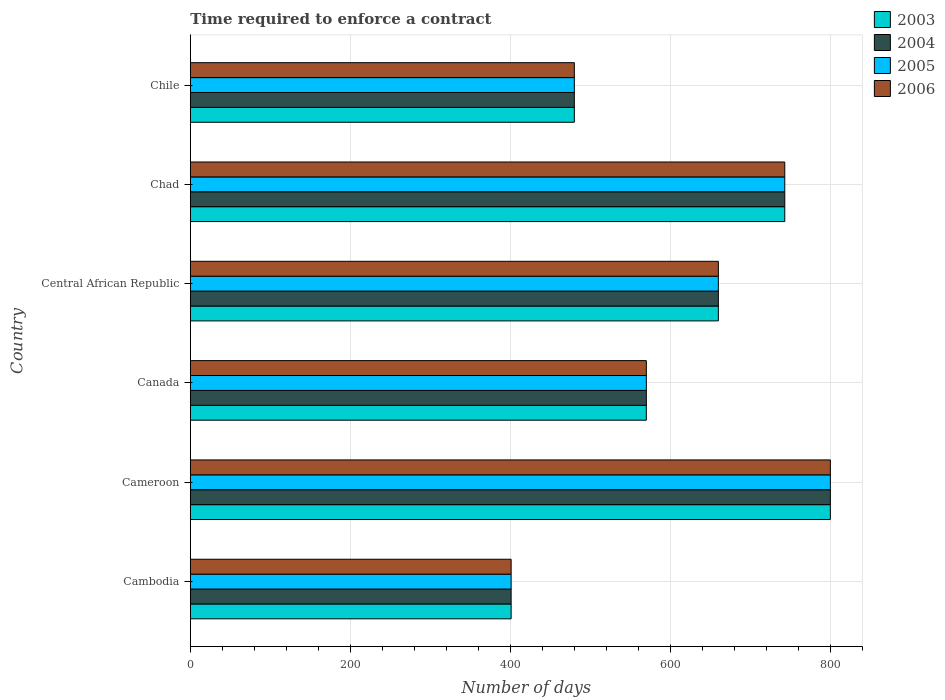How many different coloured bars are there?
Offer a very short reply. 4. How many groups of bars are there?
Provide a short and direct response. 6. How many bars are there on the 3rd tick from the bottom?
Keep it short and to the point. 4. What is the label of the 4th group of bars from the top?
Give a very brief answer. Canada. What is the number of days required to enforce a contract in 2005 in Cameroon?
Provide a short and direct response. 800. Across all countries, what is the maximum number of days required to enforce a contract in 2005?
Provide a succinct answer. 800. Across all countries, what is the minimum number of days required to enforce a contract in 2005?
Offer a terse response. 401. In which country was the number of days required to enforce a contract in 2003 maximum?
Your response must be concise. Cameroon. In which country was the number of days required to enforce a contract in 2005 minimum?
Your response must be concise. Cambodia. What is the total number of days required to enforce a contract in 2003 in the graph?
Provide a short and direct response. 3654. What is the difference between the number of days required to enforce a contract in 2004 in Cameroon and that in Canada?
Make the answer very short. 230. What is the difference between the number of days required to enforce a contract in 2004 in Chile and the number of days required to enforce a contract in 2005 in Canada?
Your answer should be compact. -90. What is the average number of days required to enforce a contract in 2006 per country?
Provide a succinct answer. 609. What is the difference between the number of days required to enforce a contract in 2006 and number of days required to enforce a contract in 2004 in Chad?
Ensure brevity in your answer.  0. In how many countries, is the number of days required to enforce a contract in 2005 greater than 800 days?
Ensure brevity in your answer.  0. What is the ratio of the number of days required to enforce a contract in 2004 in Chad to that in Chile?
Your answer should be very brief. 1.55. Is the difference between the number of days required to enforce a contract in 2006 in Central African Republic and Chile greater than the difference between the number of days required to enforce a contract in 2004 in Central African Republic and Chile?
Make the answer very short. No. What is the difference between the highest and the lowest number of days required to enforce a contract in 2004?
Your answer should be compact. 399. In how many countries, is the number of days required to enforce a contract in 2005 greater than the average number of days required to enforce a contract in 2005 taken over all countries?
Provide a short and direct response. 3. What does the 2nd bar from the bottom in Central African Republic represents?
Offer a very short reply. 2004. Are all the bars in the graph horizontal?
Give a very brief answer. Yes. How many countries are there in the graph?
Make the answer very short. 6. What is the difference between two consecutive major ticks on the X-axis?
Provide a succinct answer. 200. Does the graph contain any zero values?
Give a very brief answer. No. Does the graph contain grids?
Provide a short and direct response. Yes. Where does the legend appear in the graph?
Offer a very short reply. Top right. What is the title of the graph?
Provide a succinct answer. Time required to enforce a contract. Does "2002" appear as one of the legend labels in the graph?
Make the answer very short. No. What is the label or title of the X-axis?
Make the answer very short. Number of days. What is the Number of days of 2003 in Cambodia?
Offer a terse response. 401. What is the Number of days of 2004 in Cambodia?
Make the answer very short. 401. What is the Number of days of 2005 in Cambodia?
Offer a terse response. 401. What is the Number of days in 2006 in Cambodia?
Provide a short and direct response. 401. What is the Number of days of 2003 in Cameroon?
Your answer should be very brief. 800. What is the Number of days of 2004 in Cameroon?
Provide a succinct answer. 800. What is the Number of days of 2005 in Cameroon?
Your answer should be very brief. 800. What is the Number of days in 2006 in Cameroon?
Keep it short and to the point. 800. What is the Number of days of 2003 in Canada?
Offer a very short reply. 570. What is the Number of days of 2004 in Canada?
Ensure brevity in your answer.  570. What is the Number of days in 2005 in Canada?
Offer a terse response. 570. What is the Number of days in 2006 in Canada?
Your response must be concise. 570. What is the Number of days of 2003 in Central African Republic?
Offer a very short reply. 660. What is the Number of days in 2004 in Central African Republic?
Offer a terse response. 660. What is the Number of days of 2005 in Central African Republic?
Your response must be concise. 660. What is the Number of days of 2006 in Central African Republic?
Your answer should be compact. 660. What is the Number of days in 2003 in Chad?
Offer a very short reply. 743. What is the Number of days in 2004 in Chad?
Keep it short and to the point. 743. What is the Number of days in 2005 in Chad?
Ensure brevity in your answer.  743. What is the Number of days of 2006 in Chad?
Ensure brevity in your answer.  743. What is the Number of days in 2003 in Chile?
Your response must be concise. 480. What is the Number of days of 2004 in Chile?
Offer a terse response. 480. What is the Number of days of 2005 in Chile?
Make the answer very short. 480. What is the Number of days in 2006 in Chile?
Give a very brief answer. 480. Across all countries, what is the maximum Number of days of 2003?
Give a very brief answer. 800. Across all countries, what is the maximum Number of days of 2004?
Offer a terse response. 800. Across all countries, what is the maximum Number of days of 2005?
Keep it short and to the point. 800. Across all countries, what is the maximum Number of days in 2006?
Offer a very short reply. 800. Across all countries, what is the minimum Number of days in 2003?
Your answer should be compact. 401. Across all countries, what is the minimum Number of days in 2004?
Offer a terse response. 401. Across all countries, what is the minimum Number of days of 2005?
Make the answer very short. 401. Across all countries, what is the minimum Number of days of 2006?
Ensure brevity in your answer.  401. What is the total Number of days in 2003 in the graph?
Offer a very short reply. 3654. What is the total Number of days in 2004 in the graph?
Ensure brevity in your answer.  3654. What is the total Number of days of 2005 in the graph?
Keep it short and to the point. 3654. What is the total Number of days of 2006 in the graph?
Your answer should be very brief. 3654. What is the difference between the Number of days of 2003 in Cambodia and that in Cameroon?
Offer a very short reply. -399. What is the difference between the Number of days of 2004 in Cambodia and that in Cameroon?
Provide a succinct answer. -399. What is the difference between the Number of days in 2005 in Cambodia and that in Cameroon?
Ensure brevity in your answer.  -399. What is the difference between the Number of days of 2006 in Cambodia and that in Cameroon?
Your response must be concise. -399. What is the difference between the Number of days in 2003 in Cambodia and that in Canada?
Offer a terse response. -169. What is the difference between the Number of days of 2004 in Cambodia and that in Canada?
Keep it short and to the point. -169. What is the difference between the Number of days in 2005 in Cambodia and that in Canada?
Your answer should be compact. -169. What is the difference between the Number of days in 2006 in Cambodia and that in Canada?
Your response must be concise. -169. What is the difference between the Number of days of 2003 in Cambodia and that in Central African Republic?
Provide a succinct answer. -259. What is the difference between the Number of days of 2004 in Cambodia and that in Central African Republic?
Provide a succinct answer. -259. What is the difference between the Number of days in 2005 in Cambodia and that in Central African Republic?
Provide a short and direct response. -259. What is the difference between the Number of days in 2006 in Cambodia and that in Central African Republic?
Provide a short and direct response. -259. What is the difference between the Number of days in 2003 in Cambodia and that in Chad?
Your response must be concise. -342. What is the difference between the Number of days of 2004 in Cambodia and that in Chad?
Provide a succinct answer. -342. What is the difference between the Number of days of 2005 in Cambodia and that in Chad?
Your answer should be very brief. -342. What is the difference between the Number of days of 2006 in Cambodia and that in Chad?
Your answer should be compact. -342. What is the difference between the Number of days of 2003 in Cambodia and that in Chile?
Provide a short and direct response. -79. What is the difference between the Number of days of 2004 in Cambodia and that in Chile?
Your answer should be compact. -79. What is the difference between the Number of days in 2005 in Cambodia and that in Chile?
Provide a short and direct response. -79. What is the difference between the Number of days of 2006 in Cambodia and that in Chile?
Give a very brief answer. -79. What is the difference between the Number of days of 2003 in Cameroon and that in Canada?
Give a very brief answer. 230. What is the difference between the Number of days in 2004 in Cameroon and that in Canada?
Your answer should be very brief. 230. What is the difference between the Number of days in 2005 in Cameroon and that in Canada?
Ensure brevity in your answer.  230. What is the difference between the Number of days in 2006 in Cameroon and that in Canada?
Your answer should be very brief. 230. What is the difference between the Number of days in 2003 in Cameroon and that in Central African Republic?
Provide a succinct answer. 140. What is the difference between the Number of days of 2004 in Cameroon and that in Central African Republic?
Your answer should be compact. 140. What is the difference between the Number of days of 2005 in Cameroon and that in Central African Republic?
Make the answer very short. 140. What is the difference between the Number of days in 2006 in Cameroon and that in Central African Republic?
Your answer should be very brief. 140. What is the difference between the Number of days in 2004 in Cameroon and that in Chad?
Provide a succinct answer. 57. What is the difference between the Number of days of 2005 in Cameroon and that in Chad?
Keep it short and to the point. 57. What is the difference between the Number of days in 2003 in Cameroon and that in Chile?
Offer a very short reply. 320. What is the difference between the Number of days in 2004 in Cameroon and that in Chile?
Offer a very short reply. 320. What is the difference between the Number of days of 2005 in Cameroon and that in Chile?
Ensure brevity in your answer.  320. What is the difference between the Number of days of 2006 in Cameroon and that in Chile?
Your answer should be very brief. 320. What is the difference between the Number of days of 2003 in Canada and that in Central African Republic?
Ensure brevity in your answer.  -90. What is the difference between the Number of days of 2004 in Canada and that in Central African Republic?
Your answer should be compact. -90. What is the difference between the Number of days in 2005 in Canada and that in Central African Republic?
Ensure brevity in your answer.  -90. What is the difference between the Number of days of 2006 in Canada and that in Central African Republic?
Offer a very short reply. -90. What is the difference between the Number of days in 2003 in Canada and that in Chad?
Offer a very short reply. -173. What is the difference between the Number of days of 2004 in Canada and that in Chad?
Your answer should be very brief. -173. What is the difference between the Number of days of 2005 in Canada and that in Chad?
Offer a terse response. -173. What is the difference between the Number of days in 2006 in Canada and that in Chad?
Offer a very short reply. -173. What is the difference between the Number of days in 2003 in Canada and that in Chile?
Offer a very short reply. 90. What is the difference between the Number of days of 2005 in Canada and that in Chile?
Your answer should be compact. 90. What is the difference between the Number of days in 2006 in Canada and that in Chile?
Provide a succinct answer. 90. What is the difference between the Number of days in 2003 in Central African Republic and that in Chad?
Your response must be concise. -83. What is the difference between the Number of days of 2004 in Central African Republic and that in Chad?
Provide a short and direct response. -83. What is the difference between the Number of days in 2005 in Central African Republic and that in Chad?
Your answer should be very brief. -83. What is the difference between the Number of days in 2006 in Central African Republic and that in Chad?
Offer a terse response. -83. What is the difference between the Number of days of 2003 in Central African Republic and that in Chile?
Offer a terse response. 180. What is the difference between the Number of days of 2004 in Central African Republic and that in Chile?
Your response must be concise. 180. What is the difference between the Number of days in 2005 in Central African Republic and that in Chile?
Provide a short and direct response. 180. What is the difference between the Number of days of 2006 in Central African Republic and that in Chile?
Your answer should be compact. 180. What is the difference between the Number of days in 2003 in Chad and that in Chile?
Your response must be concise. 263. What is the difference between the Number of days in 2004 in Chad and that in Chile?
Give a very brief answer. 263. What is the difference between the Number of days of 2005 in Chad and that in Chile?
Offer a terse response. 263. What is the difference between the Number of days of 2006 in Chad and that in Chile?
Offer a terse response. 263. What is the difference between the Number of days of 2003 in Cambodia and the Number of days of 2004 in Cameroon?
Provide a succinct answer. -399. What is the difference between the Number of days in 2003 in Cambodia and the Number of days in 2005 in Cameroon?
Keep it short and to the point. -399. What is the difference between the Number of days in 2003 in Cambodia and the Number of days in 2006 in Cameroon?
Make the answer very short. -399. What is the difference between the Number of days of 2004 in Cambodia and the Number of days of 2005 in Cameroon?
Ensure brevity in your answer.  -399. What is the difference between the Number of days of 2004 in Cambodia and the Number of days of 2006 in Cameroon?
Your answer should be compact. -399. What is the difference between the Number of days of 2005 in Cambodia and the Number of days of 2006 in Cameroon?
Give a very brief answer. -399. What is the difference between the Number of days of 2003 in Cambodia and the Number of days of 2004 in Canada?
Your answer should be compact. -169. What is the difference between the Number of days of 2003 in Cambodia and the Number of days of 2005 in Canada?
Provide a short and direct response. -169. What is the difference between the Number of days of 2003 in Cambodia and the Number of days of 2006 in Canada?
Your response must be concise. -169. What is the difference between the Number of days in 2004 in Cambodia and the Number of days in 2005 in Canada?
Make the answer very short. -169. What is the difference between the Number of days of 2004 in Cambodia and the Number of days of 2006 in Canada?
Keep it short and to the point. -169. What is the difference between the Number of days in 2005 in Cambodia and the Number of days in 2006 in Canada?
Offer a terse response. -169. What is the difference between the Number of days of 2003 in Cambodia and the Number of days of 2004 in Central African Republic?
Ensure brevity in your answer.  -259. What is the difference between the Number of days in 2003 in Cambodia and the Number of days in 2005 in Central African Republic?
Ensure brevity in your answer.  -259. What is the difference between the Number of days in 2003 in Cambodia and the Number of days in 2006 in Central African Republic?
Keep it short and to the point. -259. What is the difference between the Number of days of 2004 in Cambodia and the Number of days of 2005 in Central African Republic?
Give a very brief answer. -259. What is the difference between the Number of days of 2004 in Cambodia and the Number of days of 2006 in Central African Republic?
Give a very brief answer. -259. What is the difference between the Number of days of 2005 in Cambodia and the Number of days of 2006 in Central African Republic?
Your answer should be very brief. -259. What is the difference between the Number of days in 2003 in Cambodia and the Number of days in 2004 in Chad?
Ensure brevity in your answer.  -342. What is the difference between the Number of days in 2003 in Cambodia and the Number of days in 2005 in Chad?
Your answer should be very brief. -342. What is the difference between the Number of days in 2003 in Cambodia and the Number of days in 2006 in Chad?
Provide a short and direct response. -342. What is the difference between the Number of days in 2004 in Cambodia and the Number of days in 2005 in Chad?
Ensure brevity in your answer.  -342. What is the difference between the Number of days in 2004 in Cambodia and the Number of days in 2006 in Chad?
Offer a very short reply. -342. What is the difference between the Number of days of 2005 in Cambodia and the Number of days of 2006 in Chad?
Your answer should be compact. -342. What is the difference between the Number of days in 2003 in Cambodia and the Number of days in 2004 in Chile?
Make the answer very short. -79. What is the difference between the Number of days of 2003 in Cambodia and the Number of days of 2005 in Chile?
Offer a very short reply. -79. What is the difference between the Number of days in 2003 in Cambodia and the Number of days in 2006 in Chile?
Provide a succinct answer. -79. What is the difference between the Number of days of 2004 in Cambodia and the Number of days of 2005 in Chile?
Your answer should be very brief. -79. What is the difference between the Number of days in 2004 in Cambodia and the Number of days in 2006 in Chile?
Provide a succinct answer. -79. What is the difference between the Number of days in 2005 in Cambodia and the Number of days in 2006 in Chile?
Provide a short and direct response. -79. What is the difference between the Number of days of 2003 in Cameroon and the Number of days of 2004 in Canada?
Offer a very short reply. 230. What is the difference between the Number of days of 2003 in Cameroon and the Number of days of 2005 in Canada?
Make the answer very short. 230. What is the difference between the Number of days of 2003 in Cameroon and the Number of days of 2006 in Canada?
Make the answer very short. 230. What is the difference between the Number of days of 2004 in Cameroon and the Number of days of 2005 in Canada?
Offer a terse response. 230. What is the difference between the Number of days in 2004 in Cameroon and the Number of days in 2006 in Canada?
Ensure brevity in your answer.  230. What is the difference between the Number of days in 2005 in Cameroon and the Number of days in 2006 in Canada?
Ensure brevity in your answer.  230. What is the difference between the Number of days of 2003 in Cameroon and the Number of days of 2004 in Central African Republic?
Your answer should be compact. 140. What is the difference between the Number of days in 2003 in Cameroon and the Number of days in 2005 in Central African Republic?
Offer a terse response. 140. What is the difference between the Number of days in 2003 in Cameroon and the Number of days in 2006 in Central African Republic?
Offer a terse response. 140. What is the difference between the Number of days of 2004 in Cameroon and the Number of days of 2005 in Central African Republic?
Provide a short and direct response. 140. What is the difference between the Number of days of 2004 in Cameroon and the Number of days of 2006 in Central African Republic?
Your answer should be very brief. 140. What is the difference between the Number of days of 2005 in Cameroon and the Number of days of 2006 in Central African Republic?
Provide a succinct answer. 140. What is the difference between the Number of days in 2003 in Cameroon and the Number of days in 2006 in Chad?
Your answer should be compact. 57. What is the difference between the Number of days in 2004 in Cameroon and the Number of days in 2005 in Chad?
Keep it short and to the point. 57. What is the difference between the Number of days of 2003 in Cameroon and the Number of days of 2004 in Chile?
Your response must be concise. 320. What is the difference between the Number of days of 2003 in Cameroon and the Number of days of 2005 in Chile?
Your answer should be very brief. 320. What is the difference between the Number of days in 2003 in Cameroon and the Number of days in 2006 in Chile?
Offer a very short reply. 320. What is the difference between the Number of days of 2004 in Cameroon and the Number of days of 2005 in Chile?
Offer a very short reply. 320. What is the difference between the Number of days of 2004 in Cameroon and the Number of days of 2006 in Chile?
Offer a terse response. 320. What is the difference between the Number of days in 2005 in Cameroon and the Number of days in 2006 in Chile?
Keep it short and to the point. 320. What is the difference between the Number of days in 2003 in Canada and the Number of days in 2004 in Central African Republic?
Provide a short and direct response. -90. What is the difference between the Number of days in 2003 in Canada and the Number of days in 2005 in Central African Republic?
Offer a very short reply. -90. What is the difference between the Number of days of 2003 in Canada and the Number of days of 2006 in Central African Republic?
Your answer should be compact. -90. What is the difference between the Number of days in 2004 in Canada and the Number of days in 2005 in Central African Republic?
Keep it short and to the point. -90. What is the difference between the Number of days in 2004 in Canada and the Number of days in 2006 in Central African Republic?
Give a very brief answer. -90. What is the difference between the Number of days in 2005 in Canada and the Number of days in 2006 in Central African Republic?
Offer a terse response. -90. What is the difference between the Number of days in 2003 in Canada and the Number of days in 2004 in Chad?
Your answer should be compact. -173. What is the difference between the Number of days in 2003 in Canada and the Number of days in 2005 in Chad?
Keep it short and to the point. -173. What is the difference between the Number of days in 2003 in Canada and the Number of days in 2006 in Chad?
Ensure brevity in your answer.  -173. What is the difference between the Number of days in 2004 in Canada and the Number of days in 2005 in Chad?
Provide a short and direct response. -173. What is the difference between the Number of days of 2004 in Canada and the Number of days of 2006 in Chad?
Provide a short and direct response. -173. What is the difference between the Number of days in 2005 in Canada and the Number of days in 2006 in Chad?
Offer a very short reply. -173. What is the difference between the Number of days in 2003 in Canada and the Number of days in 2005 in Chile?
Keep it short and to the point. 90. What is the difference between the Number of days in 2004 in Canada and the Number of days in 2006 in Chile?
Provide a short and direct response. 90. What is the difference between the Number of days of 2003 in Central African Republic and the Number of days of 2004 in Chad?
Your answer should be very brief. -83. What is the difference between the Number of days in 2003 in Central African Republic and the Number of days in 2005 in Chad?
Keep it short and to the point. -83. What is the difference between the Number of days in 2003 in Central African Republic and the Number of days in 2006 in Chad?
Your response must be concise. -83. What is the difference between the Number of days of 2004 in Central African Republic and the Number of days of 2005 in Chad?
Provide a succinct answer. -83. What is the difference between the Number of days in 2004 in Central African Republic and the Number of days in 2006 in Chad?
Your answer should be very brief. -83. What is the difference between the Number of days in 2005 in Central African Republic and the Number of days in 2006 in Chad?
Offer a very short reply. -83. What is the difference between the Number of days of 2003 in Central African Republic and the Number of days of 2004 in Chile?
Your answer should be very brief. 180. What is the difference between the Number of days of 2003 in Central African Republic and the Number of days of 2005 in Chile?
Ensure brevity in your answer.  180. What is the difference between the Number of days of 2003 in Central African Republic and the Number of days of 2006 in Chile?
Offer a terse response. 180. What is the difference between the Number of days of 2004 in Central African Republic and the Number of days of 2005 in Chile?
Give a very brief answer. 180. What is the difference between the Number of days of 2004 in Central African Republic and the Number of days of 2006 in Chile?
Offer a terse response. 180. What is the difference between the Number of days in 2005 in Central African Republic and the Number of days in 2006 in Chile?
Ensure brevity in your answer.  180. What is the difference between the Number of days of 2003 in Chad and the Number of days of 2004 in Chile?
Your answer should be very brief. 263. What is the difference between the Number of days of 2003 in Chad and the Number of days of 2005 in Chile?
Your response must be concise. 263. What is the difference between the Number of days of 2003 in Chad and the Number of days of 2006 in Chile?
Your answer should be compact. 263. What is the difference between the Number of days of 2004 in Chad and the Number of days of 2005 in Chile?
Offer a very short reply. 263. What is the difference between the Number of days of 2004 in Chad and the Number of days of 2006 in Chile?
Give a very brief answer. 263. What is the difference between the Number of days in 2005 in Chad and the Number of days in 2006 in Chile?
Offer a very short reply. 263. What is the average Number of days of 2003 per country?
Offer a terse response. 609. What is the average Number of days of 2004 per country?
Offer a terse response. 609. What is the average Number of days of 2005 per country?
Give a very brief answer. 609. What is the average Number of days of 2006 per country?
Provide a short and direct response. 609. What is the difference between the Number of days of 2003 and Number of days of 2006 in Cambodia?
Your response must be concise. 0. What is the difference between the Number of days of 2004 and Number of days of 2005 in Cambodia?
Provide a succinct answer. 0. What is the difference between the Number of days in 2003 and Number of days in 2005 in Cameroon?
Offer a very short reply. 0. What is the difference between the Number of days in 2003 and Number of days in 2006 in Cameroon?
Your response must be concise. 0. What is the difference between the Number of days of 2003 and Number of days of 2005 in Canada?
Ensure brevity in your answer.  0. What is the difference between the Number of days of 2003 and Number of days of 2006 in Canada?
Your answer should be very brief. 0. What is the difference between the Number of days in 2004 and Number of days in 2005 in Canada?
Make the answer very short. 0. What is the difference between the Number of days of 2005 and Number of days of 2006 in Canada?
Offer a very short reply. 0. What is the difference between the Number of days of 2003 and Number of days of 2006 in Central African Republic?
Keep it short and to the point. 0. What is the difference between the Number of days in 2004 and Number of days in 2005 in Central African Republic?
Keep it short and to the point. 0. What is the difference between the Number of days in 2004 and Number of days in 2006 in Central African Republic?
Ensure brevity in your answer.  0. What is the difference between the Number of days of 2005 and Number of days of 2006 in Central African Republic?
Provide a short and direct response. 0. What is the difference between the Number of days of 2003 and Number of days of 2004 in Chad?
Your response must be concise. 0. What is the difference between the Number of days of 2003 and Number of days of 2005 in Chad?
Keep it short and to the point. 0. What is the difference between the Number of days of 2003 and Number of days of 2006 in Chad?
Offer a terse response. 0. What is the difference between the Number of days of 2004 and Number of days of 2006 in Chad?
Your answer should be compact. 0. What is the difference between the Number of days in 2005 and Number of days in 2006 in Chad?
Your response must be concise. 0. What is the difference between the Number of days in 2003 and Number of days in 2006 in Chile?
Your response must be concise. 0. What is the difference between the Number of days in 2005 and Number of days in 2006 in Chile?
Offer a very short reply. 0. What is the ratio of the Number of days in 2003 in Cambodia to that in Cameroon?
Ensure brevity in your answer.  0.5. What is the ratio of the Number of days in 2004 in Cambodia to that in Cameroon?
Your response must be concise. 0.5. What is the ratio of the Number of days in 2005 in Cambodia to that in Cameroon?
Your response must be concise. 0.5. What is the ratio of the Number of days in 2006 in Cambodia to that in Cameroon?
Offer a very short reply. 0.5. What is the ratio of the Number of days of 2003 in Cambodia to that in Canada?
Your answer should be compact. 0.7. What is the ratio of the Number of days of 2004 in Cambodia to that in Canada?
Provide a short and direct response. 0.7. What is the ratio of the Number of days of 2005 in Cambodia to that in Canada?
Offer a very short reply. 0.7. What is the ratio of the Number of days in 2006 in Cambodia to that in Canada?
Ensure brevity in your answer.  0.7. What is the ratio of the Number of days in 2003 in Cambodia to that in Central African Republic?
Offer a very short reply. 0.61. What is the ratio of the Number of days of 2004 in Cambodia to that in Central African Republic?
Provide a short and direct response. 0.61. What is the ratio of the Number of days in 2005 in Cambodia to that in Central African Republic?
Your answer should be very brief. 0.61. What is the ratio of the Number of days of 2006 in Cambodia to that in Central African Republic?
Provide a short and direct response. 0.61. What is the ratio of the Number of days in 2003 in Cambodia to that in Chad?
Your answer should be very brief. 0.54. What is the ratio of the Number of days of 2004 in Cambodia to that in Chad?
Your response must be concise. 0.54. What is the ratio of the Number of days of 2005 in Cambodia to that in Chad?
Keep it short and to the point. 0.54. What is the ratio of the Number of days in 2006 in Cambodia to that in Chad?
Your answer should be very brief. 0.54. What is the ratio of the Number of days in 2003 in Cambodia to that in Chile?
Your response must be concise. 0.84. What is the ratio of the Number of days in 2004 in Cambodia to that in Chile?
Provide a short and direct response. 0.84. What is the ratio of the Number of days of 2005 in Cambodia to that in Chile?
Offer a very short reply. 0.84. What is the ratio of the Number of days in 2006 in Cambodia to that in Chile?
Ensure brevity in your answer.  0.84. What is the ratio of the Number of days of 2003 in Cameroon to that in Canada?
Your answer should be compact. 1.4. What is the ratio of the Number of days of 2004 in Cameroon to that in Canada?
Make the answer very short. 1.4. What is the ratio of the Number of days of 2005 in Cameroon to that in Canada?
Provide a short and direct response. 1.4. What is the ratio of the Number of days of 2006 in Cameroon to that in Canada?
Ensure brevity in your answer.  1.4. What is the ratio of the Number of days in 2003 in Cameroon to that in Central African Republic?
Your response must be concise. 1.21. What is the ratio of the Number of days of 2004 in Cameroon to that in Central African Republic?
Give a very brief answer. 1.21. What is the ratio of the Number of days of 2005 in Cameroon to that in Central African Republic?
Offer a very short reply. 1.21. What is the ratio of the Number of days of 2006 in Cameroon to that in Central African Republic?
Ensure brevity in your answer.  1.21. What is the ratio of the Number of days in 2003 in Cameroon to that in Chad?
Make the answer very short. 1.08. What is the ratio of the Number of days of 2004 in Cameroon to that in Chad?
Provide a succinct answer. 1.08. What is the ratio of the Number of days in 2005 in Cameroon to that in Chad?
Make the answer very short. 1.08. What is the ratio of the Number of days in 2006 in Cameroon to that in Chad?
Your answer should be very brief. 1.08. What is the ratio of the Number of days in 2004 in Cameroon to that in Chile?
Ensure brevity in your answer.  1.67. What is the ratio of the Number of days of 2005 in Cameroon to that in Chile?
Provide a succinct answer. 1.67. What is the ratio of the Number of days in 2006 in Cameroon to that in Chile?
Provide a succinct answer. 1.67. What is the ratio of the Number of days of 2003 in Canada to that in Central African Republic?
Make the answer very short. 0.86. What is the ratio of the Number of days in 2004 in Canada to that in Central African Republic?
Provide a succinct answer. 0.86. What is the ratio of the Number of days of 2005 in Canada to that in Central African Republic?
Your answer should be compact. 0.86. What is the ratio of the Number of days of 2006 in Canada to that in Central African Republic?
Ensure brevity in your answer.  0.86. What is the ratio of the Number of days of 2003 in Canada to that in Chad?
Provide a succinct answer. 0.77. What is the ratio of the Number of days in 2004 in Canada to that in Chad?
Keep it short and to the point. 0.77. What is the ratio of the Number of days of 2005 in Canada to that in Chad?
Make the answer very short. 0.77. What is the ratio of the Number of days in 2006 in Canada to that in Chad?
Provide a short and direct response. 0.77. What is the ratio of the Number of days in 2003 in Canada to that in Chile?
Your response must be concise. 1.19. What is the ratio of the Number of days of 2004 in Canada to that in Chile?
Provide a short and direct response. 1.19. What is the ratio of the Number of days in 2005 in Canada to that in Chile?
Your response must be concise. 1.19. What is the ratio of the Number of days in 2006 in Canada to that in Chile?
Offer a very short reply. 1.19. What is the ratio of the Number of days of 2003 in Central African Republic to that in Chad?
Your answer should be very brief. 0.89. What is the ratio of the Number of days in 2004 in Central African Republic to that in Chad?
Your response must be concise. 0.89. What is the ratio of the Number of days of 2005 in Central African Republic to that in Chad?
Offer a very short reply. 0.89. What is the ratio of the Number of days of 2006 in Central African Republic to that in Chad?
Ensure brevity in your answer.  0.89. What is the ratio of the Number of days of 2003 in Central African Republic to that in Chile?
Provide a succinct answer. 1.38. What is the ratio of the Number of days in 2004 in Central African Republic to that in Chile?
Keep it short and to the point. 1.38. What is the ratio of the Number of days of 2005 in Central African Republic to that in Chile?
Keep it short and to the point. 1.38. What is the ratio of the Number of days of 2006 in Central African Republic to that in Chile?
Your answer should be compact. 1.38. What is the ratio of the Number of days of 2003 in Chad to that in Chile?
Your answer should be very brief. 1.55. What is the ratio of the Number of days of 2004 in Chad to that in Chile?
Make the answer very short. 1.55. What is the ratio of the Number of days of 2005 in Chad to that in Chile?
Ensure brevity in your answer.  1.55. What is the ratio of the Number of days in 2006 in Chad to that in Chile?
Ensure brevity in your answer.  1.55. What is the difference between the highest and the second highest Number of days of 2003?
Provide a succinct answer. 57. What is the difference between the highest and the second highest Number of days in 2004?
Your answer should be very brief. 57. What is the difference between the highest and the lowest Number of days of 2003?
Your answer should be compact. 399. What is the difference between the highest and the lowest Number of days in 2004?
Offer a very short reply. 399. What is the difference between the highest and the lowest Number of days in 2005?
Give a very brief answer. 399. What is the difference between the highest and the lowest Number of days of 2006?
Offer a very short reply. 399. 